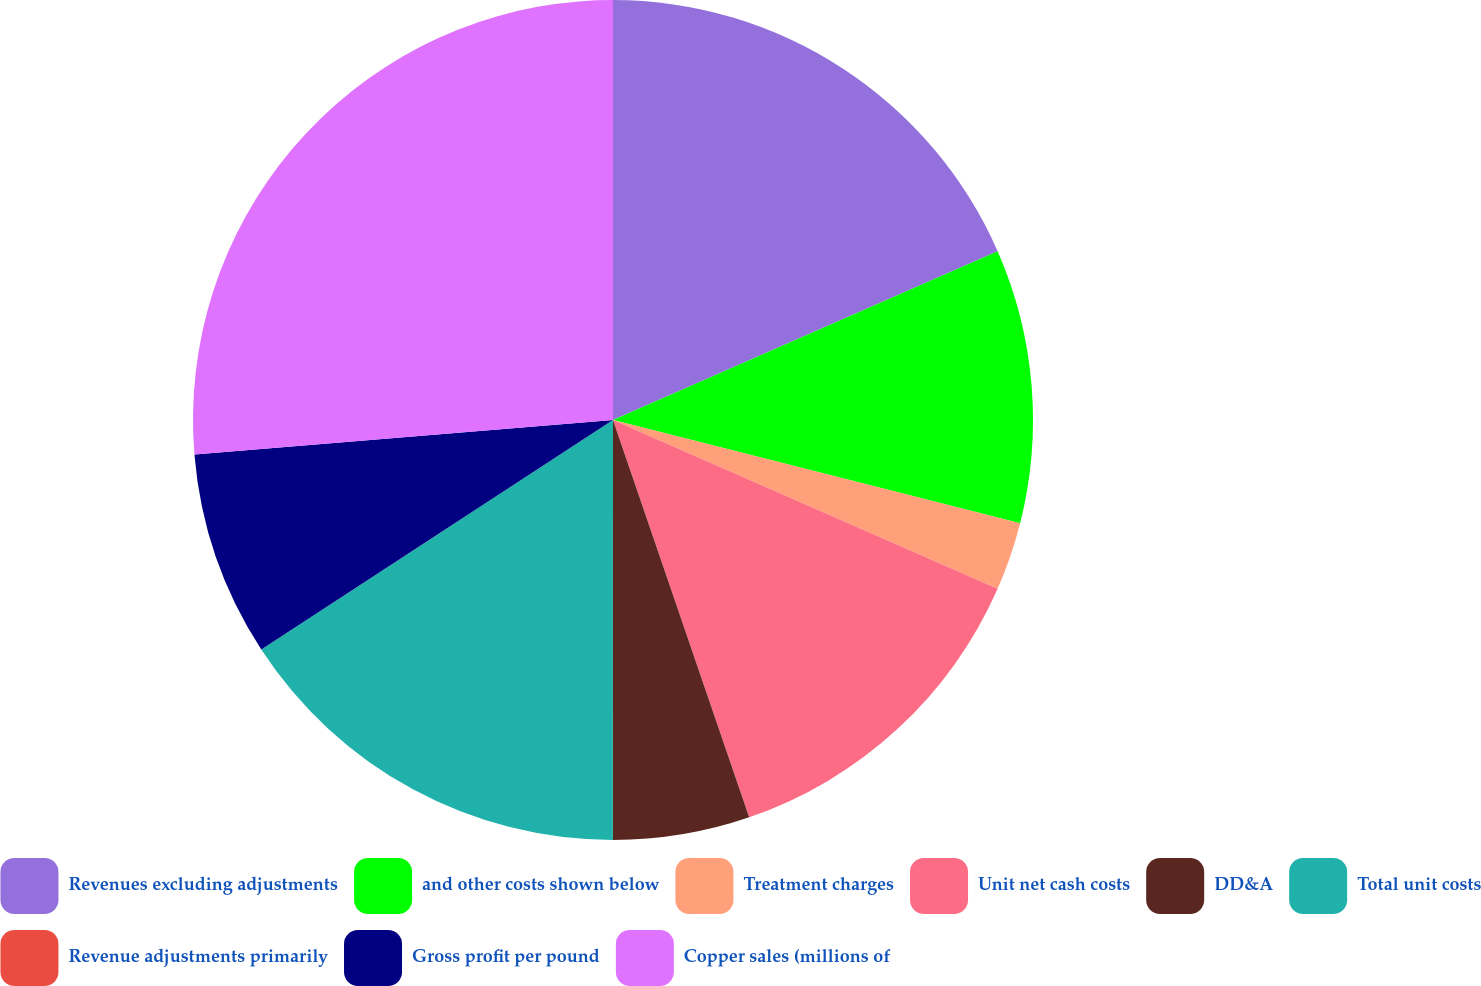<chart> <loc_0><loc_0><loc_500><loc_500><pie_chart><fcel>Revenues excluding adjustments<fcel>and other costs shown below<fcel>Treatment charges<fcel>Unit net cash costs<fcel>DD&A<fcel>Total unit costs<fcel>Revenue adjustments primarily<fcel>Gross profit per pound<fcel>Copper sales (millions of<nl><fcel>18.42%<fcel>10.53%<fcel>2.63%<fcel>13.16%<fcel>5.26%<fcel>15.79%<fcel>0.0%<fcel>7.89%<fcel>26.31%<nl></chart> 